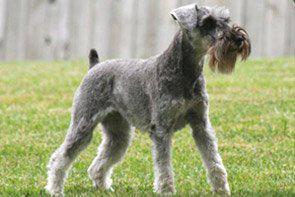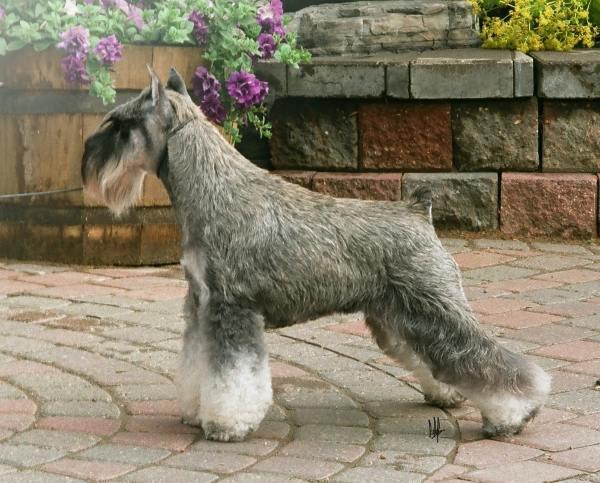The first image is the image on the left, the second image is the image on the right. For the images shown, is this caption "There are two dogs in total." true? Answer yes or no. Yes. The first image is the image on the left, the second image is the image on the right. Given the left and right images, does the statement "The right and left images contain the same number of dogs." hold true? Answer yes or no. Yes. 